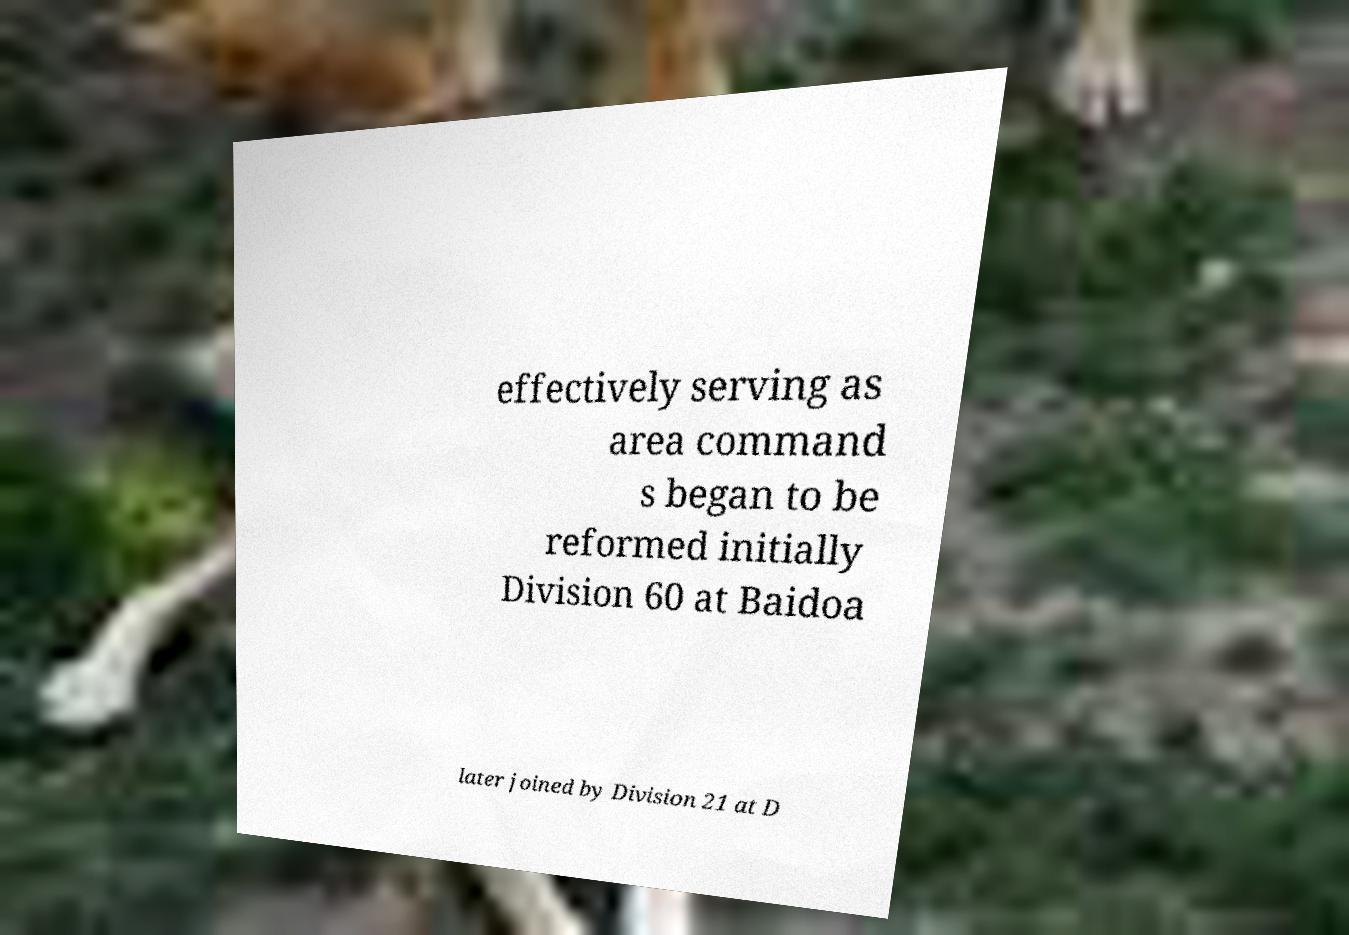There's text embedded in this image that I need extracted. Can you transcribe it verbatim? effectively serving as area command s began to be reformed initially Division 60 at Baidoa later joined by Division 21 at D 